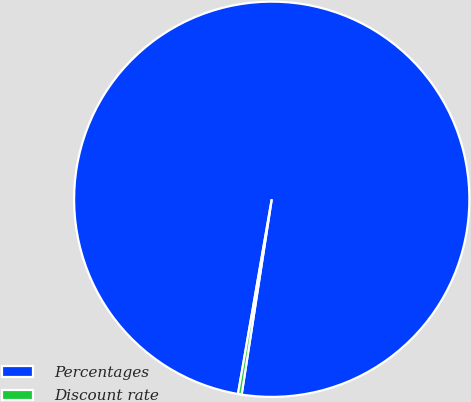<chart> <loc_0><loc_0><loc_500><loc_500><pie_chart><fcel>Percentages<fcel>Discount rate<nl><fcel>99.7%<fcel>0.3%<nl></chart> 